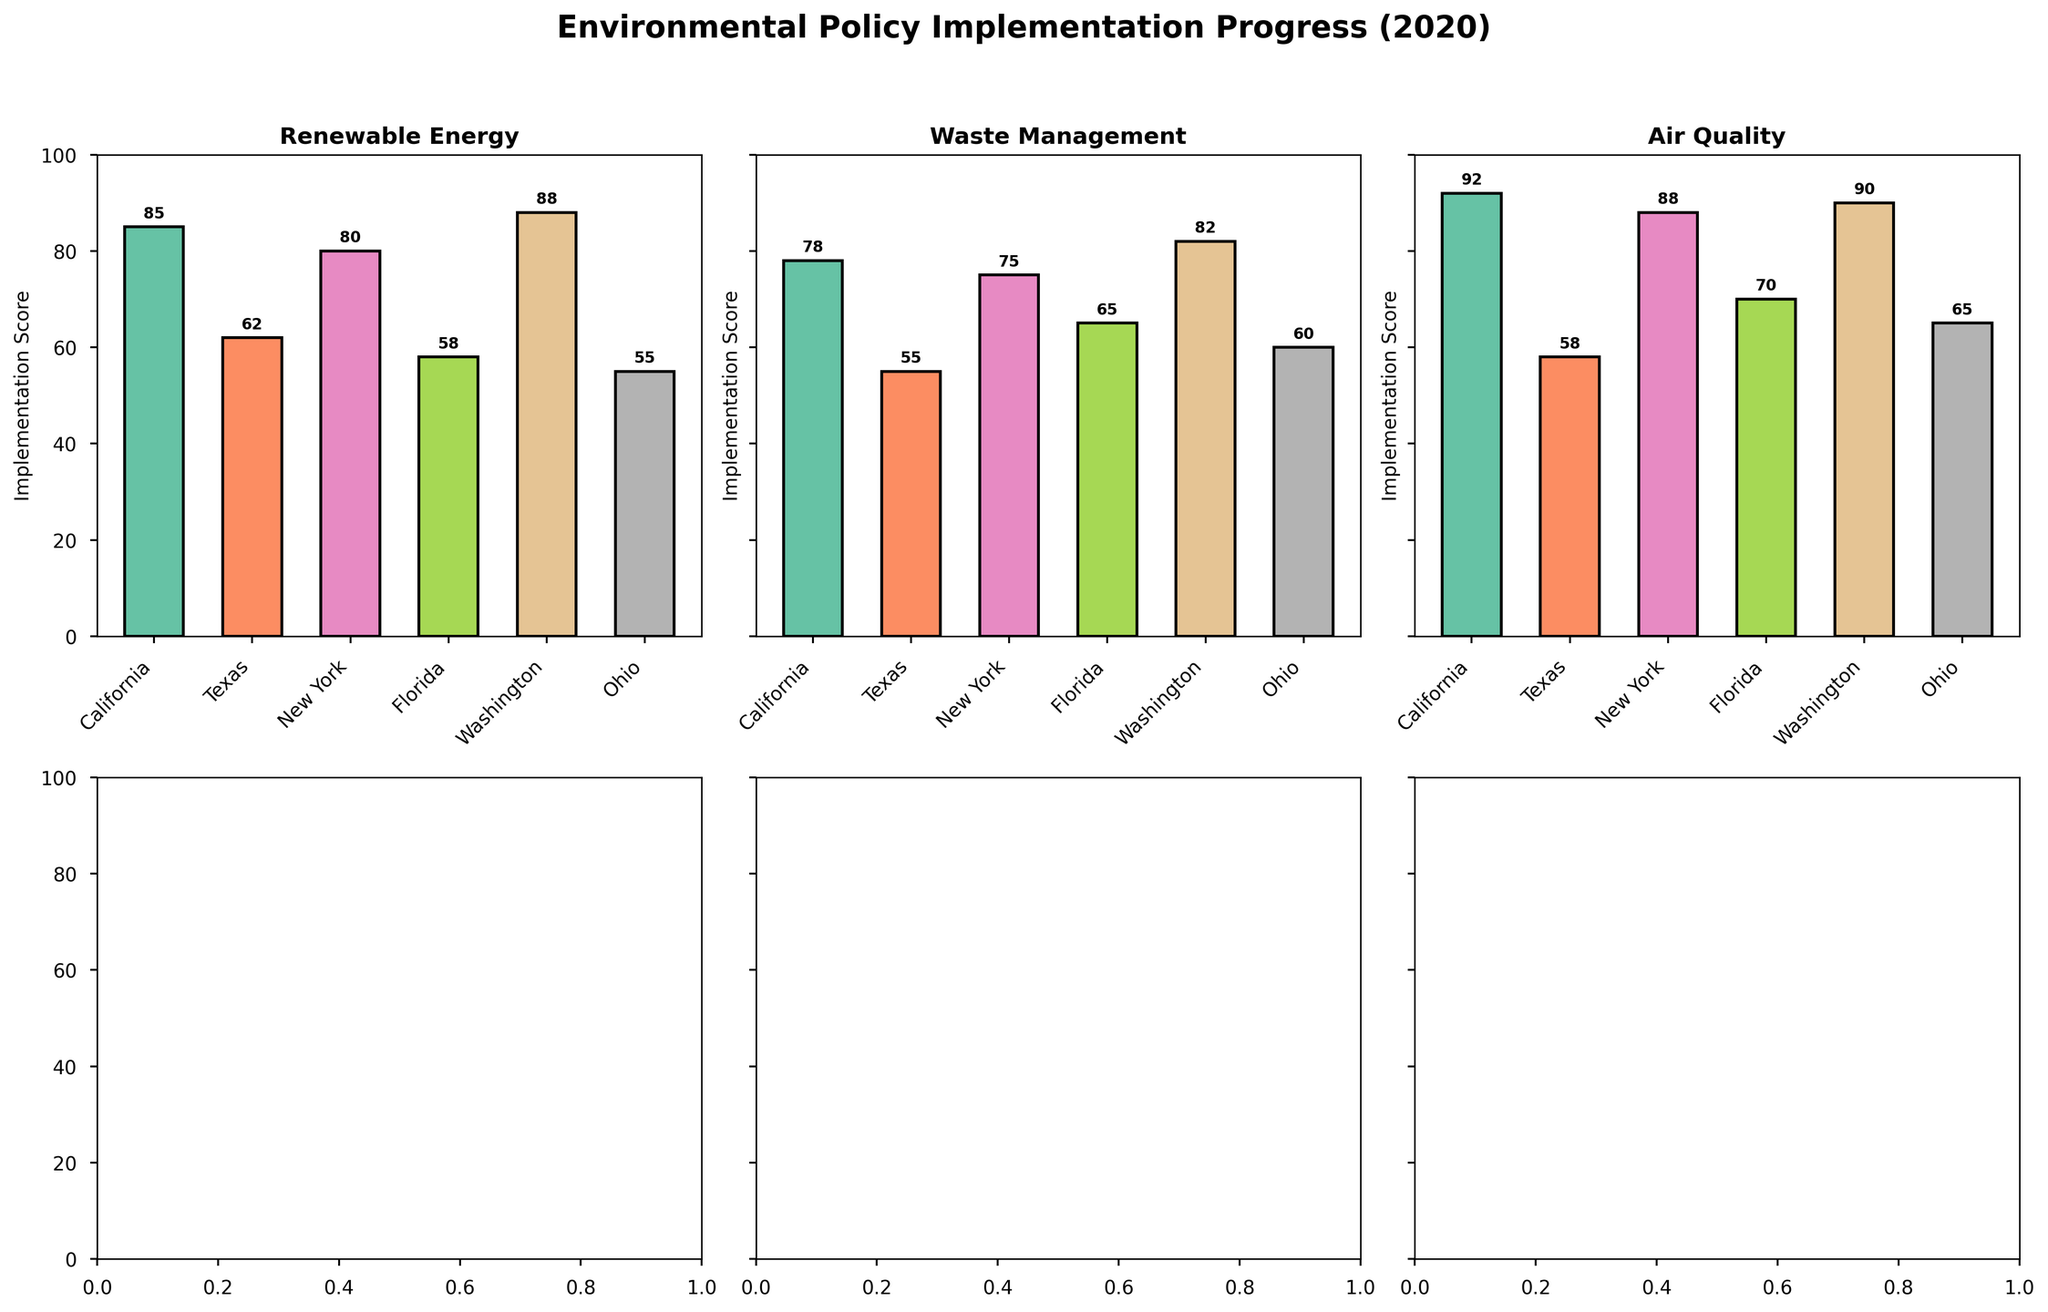What is the highest implementation score for Air Quality? The highest implementation score for Air Quality is identified by looking at the respective subplot for Air Quality and finding the tallest bar. The figure shows that Washington has the highest implementation score.
Answer: Washington Which state has the lowest Renewable Energy implementation score? The lowest implementation score for Renewable Energy is found in the subplot for Renewable Energy. The figure shows that Ohio has the lowest score.
Answer: Ohio Compare the implementation scores of Air Quality between California and New York. Which state has a higher score? To compare the implementation scores, observe the subplot for Air Quality. California has a score of 92, while New York has a score of 88.
Answer: California What's the average implementation score for Waste Management across all states? The scores for Waste Management are 78 (California), 55 (Texas), 75 (New York), 65 (Florida), 82 (Washington), and 60 (Ohio). Adding them gives 415, and there are 6 states, so the average is 415/6 = 69.17.
Answer: 69.17 How many policy areas are displayed in the figure? The policy areas are seen as the titles of each subplot. The figure includes Renewable Energy, Waste Management, and Air Quality. Thus, there are three policy areas displayed.
Answer: 3 Which policy area shows the most variation in implementation scores across states? By looking at the height differences of bars in each subplot, Renewable Energy shows the most variation with scores ranging from 55 to 88.
Answer: Renewable Energy Between Florida and Texas, which state has a higher Waste Management implementation score? Observing the Waste Management subplot, Florida has a score of 65, and Texas has a score of 55. Thus, Florida has a higher score.
Answer: Florida Which state has the most consistent scores across the different policy areas? To find the most consistent state, look for the state with the smallest variation in bar heights across all subplots. Washington appears to have relatively consistent scores of 88, 82, and 90 across the different policy areas.
Answer: Washington Combining the scores for Air Quality and Renewable Energy, does Texas have a total score greater than 100? Texas has scores of 62 (Renewable Energy) and 58 (Air Quality). Adding these gives 62 + 58 = 120, which is greater than 100.
Answer: Yes 